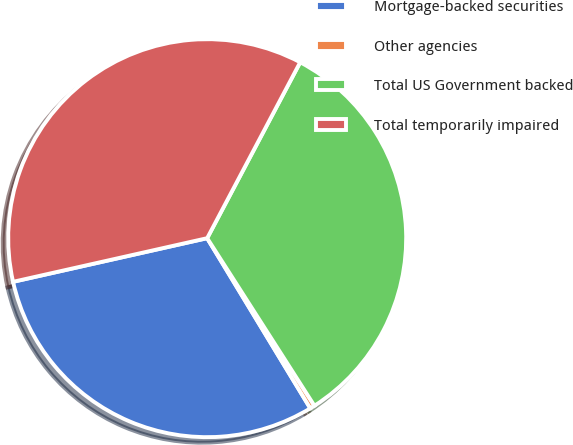<chart> <loc_0><loc_0><loc_500><loc_500><pie_chart><fcel>Mortgage-backed securities<fcel>Other agencies<fcel>Total US Government backed<fcel>Total temporarily impaired<nl><fcel>30.15%<fcel>0.39%<fcel>33.2%<fcel>36.26%<nl></chart> 